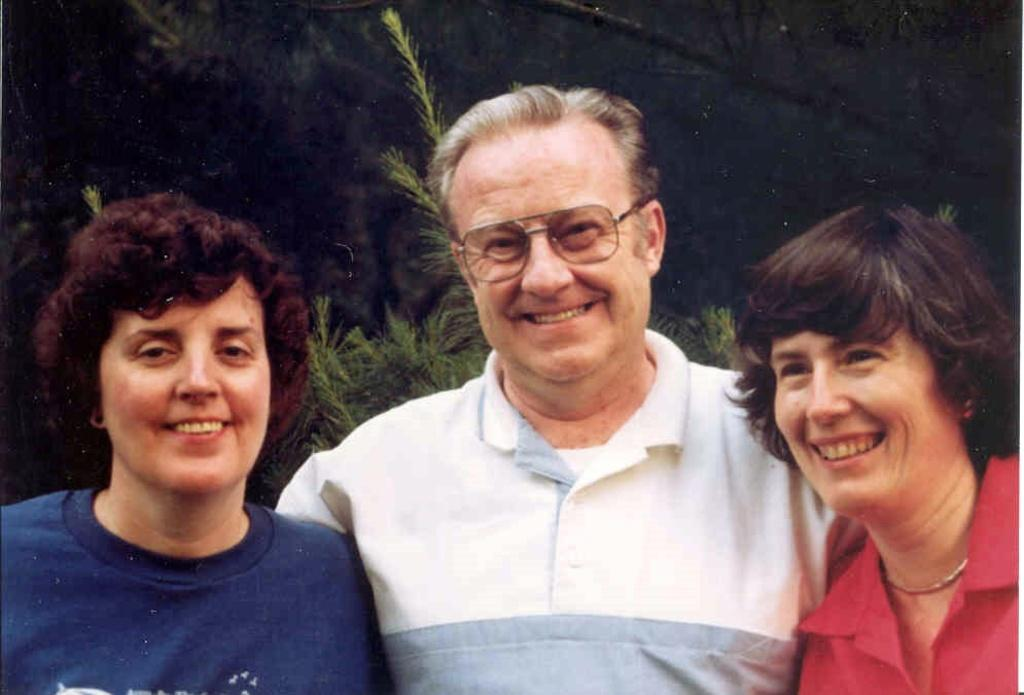How many people are in the image? There are three persons in the image. Can you describe any specific features of one of the persons? One person is wearing spectacles. What can be seen in the background of the image? There are trees in the background of the image. What type of flesh can be seen on the person wearing spectacles in the image? There is no flesh visible on the person wearing spectacles in the image. 